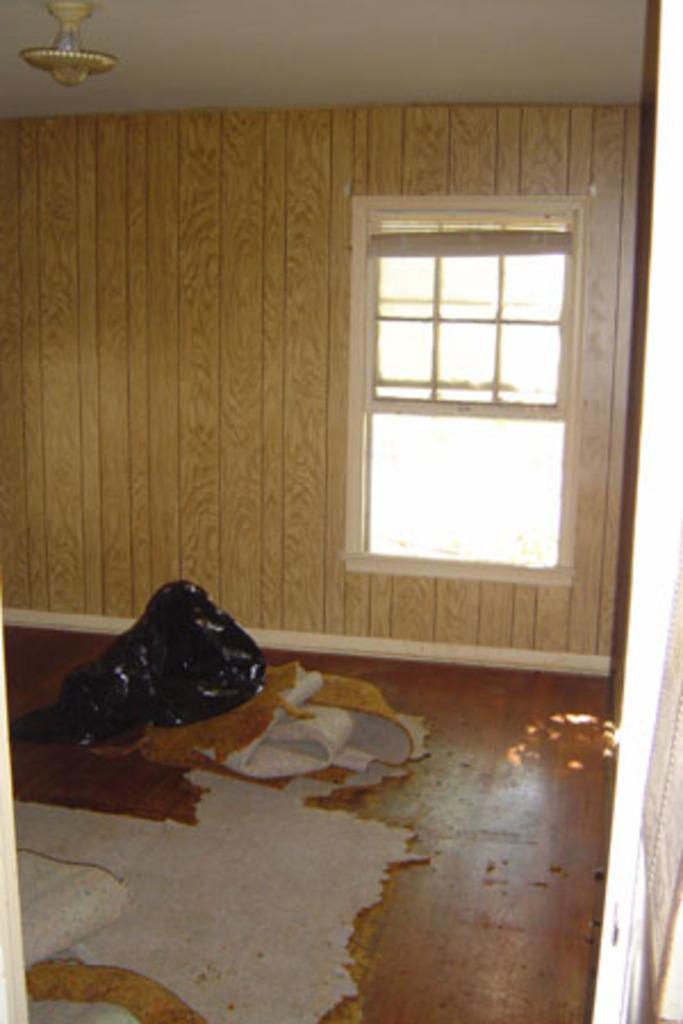Can you describe this image briefly? In this image I can see on the right side there is a glass window, at the bottom there is the floor mat. At the top it looks like a light. 